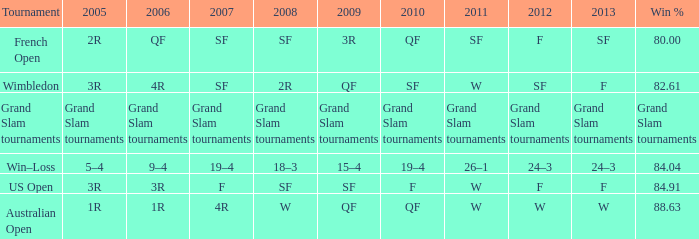When in 2008 that has a 2007 of f? SF. 